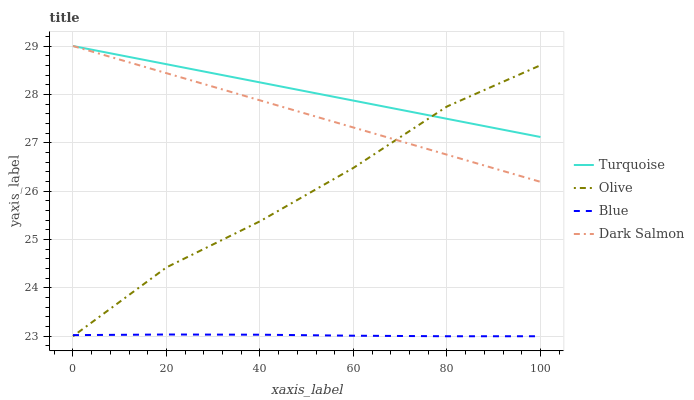Does Blue have the minimum area under the curve?
Answer yes or no. Yes. Does Turquoise have the maximum area under the curve?
Answer yes or no. Yes. Does Turquoise have the minimum area under the curve?
Answer yes or no. No. Does Blue have the maximum area under the curve?
Answer yes or no. No. Is Turquoise the smoothest?
Answer yes or no. Yes. Is Olive the roughest?
Answer yes or no. Yes. Is Blue the smoothest?
Answer yes or no. No. Is Blue the roughest?
Answer yes or no. No. Does Olive have the lowest value?
Answer yes or no. Yes. Does Turquoise have the lowest value?
Answer yes or no. No. Does Dark Salmon have the highest value?
Answer yes or no. Yes. Does Blue have the highest value?
Answer yes or no. No. Is Blue less than Turquoise?
Answer yes or no. Yes. Is Dark Salmon greater than Blue?
Answer yes or no. Yes. Does Olive intersect Turquoise?
Answer yes or no. Yes. Is Olive less than Turquoise?
Answer yes or no. No. Is Olive greater than Turquoise?
Answer yes or no. No. Does Blue intersect Turquoise?
Answer yes or no. No. 